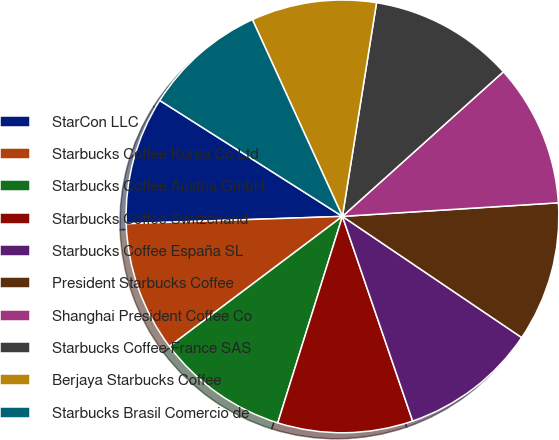Convert chart. <chart><loc_0><loc_0><loc_500><loc_500><pie_chart><fcel>StarCon LLC<fcel>Starbucks Coffee Korea Co Ltd<fcel>Starbucks Coffee Austria GmbH<fcel>Starbucks Coffee Switzerland<fcel>Starbucks Coffee España SL<fcel>President Starbucks Coffee<fcel>Shanghai President Coffee Co<fcel>Starbucks Coffee France SAS<fcel>Berjaya Starbucks Coffee<fcel>Starbucks Brasil Comercio de<nl><fcel>9.54%<fcel>9.72%<fcel>9.91%<fcel>10.09%<fcel>10.28%<fcel>10.46%<fcel>10.65%<fcel>10.83%<fcel>9.35%<fcel>9.17%<nl></chart> 